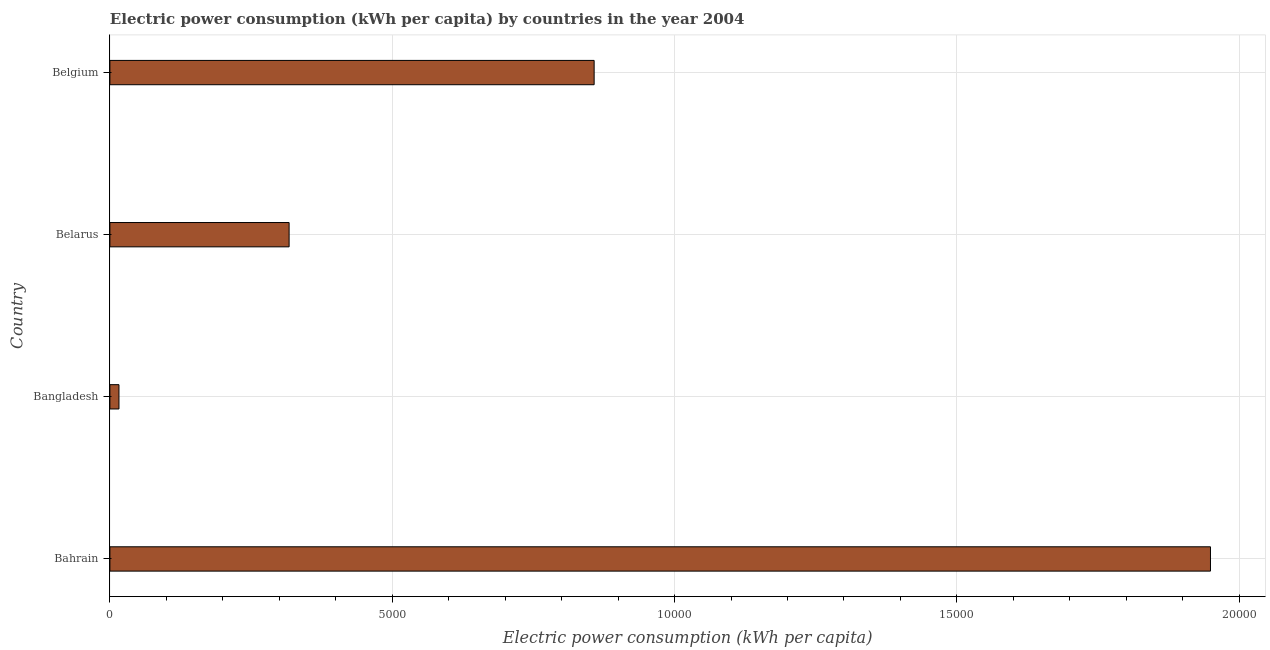Does the graph contain any zero values?
Your answer should be very brief. No. Does the graph contain grids?
Offer a terse response. Yes. What is the title of the graph?
Offer a very short reply. Electric power consumption (kWh per capita) by countries in the year 2004. What is the label or title of the X-axis?
Offer a very short reply. Electric power consumption (kWh per capita). What is the electric power consumption in Belarus?
Keep it short and to the point. 3174.1. Across all countries, what is the maximum electric power consumption?
Make the answer very short. 1.95e+04. Across all countries, what is the minimum electric power consumption?
Offer a terse response. 160.79. In which country was the electric power consumption maximum?
Offer a terse response. Bahrain. What is the sum of the electric power consumption?
Ensure brevity in your answer.  3.14e+04. What is the difference between the electric power consumption in Bangladesh and Belgium?
Provide a succinct answer. -8415.43. What is the average electric power consumption per country?
Your answer should be compact. 7850.68. What is the median electric power consumption?
Offer a very short reply. 5875.16. What is the ratio of the electric power consumption in Bahrain to that in Belgium?
Make the answer very short. 2.27. Is the difference between the electric power consumption in Bahrain and Bangladesh greater than the difference between any two countries?
Give a very brief answer. Yes. What is the difference between the highest and the second highest electric power consumption?
Offer a very short reply. 1.09e+04. What is the difference between the highest and the lowest electric power consumption?
Your answer should be very brief. 1.93e+04. How many bars are there?
Give a very brief answer. 4. How many countries are there in the graph?
Your answer should be compact. 4. What is the difference between two consecutive major ticks on the X-axis?
Ensure brevity in your answer.  5000. Are the values on the major ticks of X-axis written in scientific E-notation?
Make the answer very short. No. What is the Electric power consumption (kWh per capita) in Bahrain?
Offer a very short reply. 1.95e+04. What is the Electric power consumption (kWh per capita) in Bangladesh?
Give a very brief answer. 160.79. What is the Electric power consumption (kWh per capita) in Belarus?
Your answer should be compact. 3174.1. What is the Electric power consumption (kWh per capita) of Belgium?
Your response must be concise. 8576.22. What is the difference between the Electric power consumption (kWh per capita) in Bahrain and Bangladesh?
Offer a terse response. 1.93e+04. What is the difference between the Electric power consumption (kWh per capita) in Bahrain and Belarus?
Your answer should be compact. 1.63e+04. What is the difference between the Electric power consumption (kWh per capita) in Bahrain and Belgium?
Offer a terse response. 1.09e+04. What is the difference between the Electric power consumption (kWh per capita) in Bangladesh and Belarus?
Offer a very short reply. -3013.31. What is the difference between the Electric power consumption (kWh per capita) in Bangladesh and Belgium?
Your answer should be compact. -8415.44. What is the difference between the Electric power consumption (kWh per capita) in Belarus and Belgium?
Your response must be concise. -5402.12. What is the ratio of the Electric power consumption (kWh per capita) in Bahrain to that in Bangladesh?
Your answer should be very brief. 121.22. What is the ratio of the Electric power consumption (kWh per capita) in Bahrain to that in Belarus?
Offer a terse response. 6.14. What is the ratio of the Electric power consumption (kWh per capita) in Bahrain to that in Belgium?
Your answer should be compact. 2.27. What is the ratio of the Electric power consumption (kWh per capita) in Bangladesh to that in Belarus?
Keep it short and to the point. 0.05. What is the ratio of the Electric power consumption (kWh per capita) in Bangladesh to that in Belgium?
Make the answer very short. 0.02. What is the ratio of the Electric power consumption (kWh per capita) in Belarus to that in Belgium?
Offer a terse response. 0.37. 